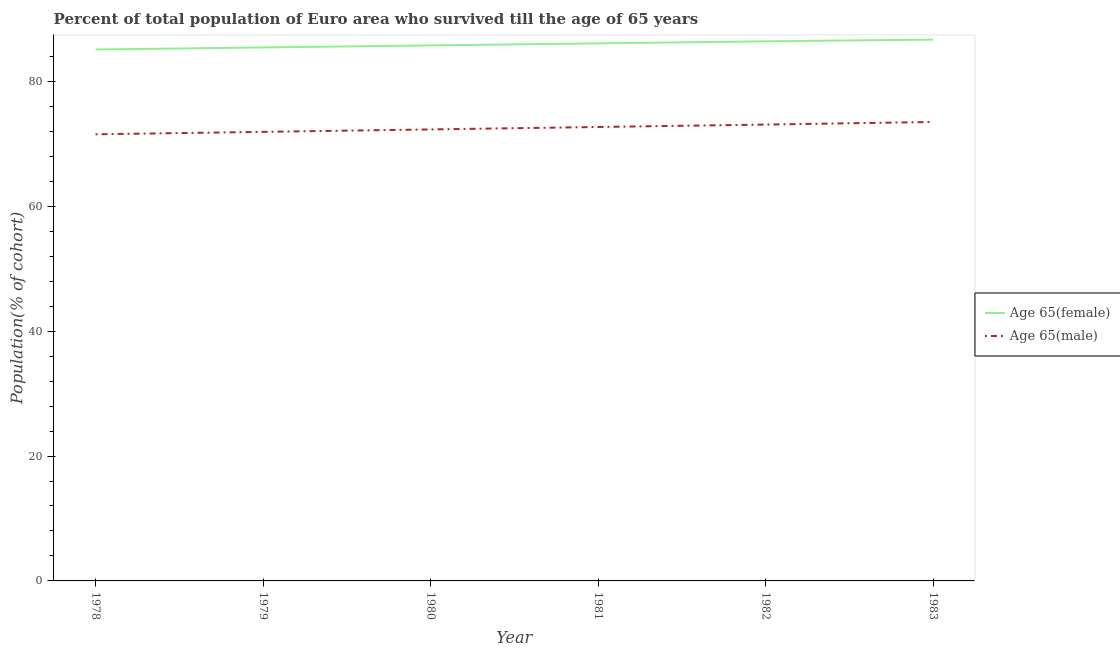How many different coloured lines are there?
Your response must be concise. 2. What is the percentage of female population who survived till age of 65 in 1982?
Make the answer very short. 86.42. Across all years, what is the maximum percentage of female population who survived till age of 65?
Provide a short and direct response. 86.69. Across all years, what is the minimum percentage of male population who survived till age of 65?
Offer a very short reply. 71.53. In which year was the percentage of male population who survived till age of 65 minimum?
Give a very brief answer. 1978. What is the total percentage of male population who survived till age of 65 in the graph?
Offer a terse response. 435.04. What is the difference between the percentage of male population who survived till age of 65 in 1981 and that in 1982?
Offer a terse response. -0.39. What is the difference between the percentage of male population who survived till age of 65 in 1983 and the percentage of female population who survived till age of 65 in 1978?
Provide a short and direct response. -11.61. What is the average percentage of male population who survived till age of 65 per year?
Provide a short and direct response. 72.51. In the year 1983, what is the difference between the percentage of female population who survived till age of 65 and percentage of male population who survived till age of 65?
Provide a succinct answer. 13.19. What is the ratio of the percentage of female population who survived till age of 65 in 1978 to that in 1979?
Give a very brief answer. 1. Is the percentage of female population who survived till age of 65 in 1980 less than that in 1983?
Your response must be concise. Yes. What is the difference between the highest and the second highest percentage of female population who survived till age of 65?
Make the answer very short. 0.28. What is the difference between the highest and the lowest percentage of male population who survived till age of 65?
Provide a succinct answer. 1.97. Is the sum of the percentage of male population who survived till age of 65 in 1978 and 1982 greater than the maximum percentage of female population who survived till age of 65 across all years?
Keep it short and to the point. Yes. Does the percentage of female population who survived till age of 65 monotonically increase over the years?
Make the answer very short. Yes. Is the percentage of male population who survived till age of 65 strictly greater than the percentage of female population who survived till age of 65 over the years?
Your response must be concise. No. Is the percentage of male population who survived till age of 65 strictly less than the percentage of female population who survived till age of 65 over the years?
Give a very brief answer. Yes. How many lines are there?
Offer a very short reply. 2. How many years are there in the graph?
Give a very brief answer. 6. What is the difference between two consecutive major ticks on the Y-axis?
Ensure brevity in your answer.  20. Are the values on the major ticks of Y-axis written in scientific E-notation?
Offer a terse response. No. Does the graph contain grids?
Provide a succinct answer. No. Where does the legend appear in the graph?
Ensure brevity in your answer.  Center right. How many legend labels are there?
Give a very brief answer. 2. What is the title of the graph?
Your answer should be compact. Percent of total population of Euro area who survived till the age of 65 years. What is the label or title of the Y-axis?
Ensure brevity in your answer.  Population(% of cohort). What is the Population(% of cohort) in Age 65(female) in 1978?
Your answer should be very brief. 85.11. What is the Population(% of cohort) in Age 65(male) in 1978?
Your answer should be compact. 71.53. What is the Population(% of cohort) in Age 65(female) in 1979?
Keep it short and to the point. 85.44. What is the Population(% of cohort) of Age 65(male) in 1979?
Make the answer very short. 71.92. What is the Population(% of cohort) of Age 65(female) in 1980?
Make the answer very short. 85.76. What is the Population(% of cohort) in Age 65(male) in 1980?
Make the answer very short. 72.31. What is the Population(% of cohort) in Age 65(female) in 1981?
Your answer should be compact. 86.09. What is the Population(% of cohort) of Age 65(male) in 1981?
Ensure brevity in your answer.  72.7. What is the Population(% of cohort) of Age 65(female) in 1982?
Keep it short and to the point. 86.42. What is the Population(% of cohort) in Age 65(male) in 1982?
Ensure brevity in your answer.  73.09. What is the Population(% of cohort) in Age 65(female) in 1983?
Provide a succinct answer. 86.69. What is the Population(% of cohort) of Age 65(male) in 1983?
Offer a very short reply. 73.5. Across all years, what is the maximum Population(% of cohort) of Age 65(female)?
Offer a very short reply. 86.69. Across all years, what is the maximum Population(% of cohort) in Age 65(male)?
Provide a succinct answer. 73.5. Across all years, what is the minimum Population(% of cohort) in Age 65(female)?
Your response must be concise. 85.11. Across all years, what is the minimum Population(% of cohort) in Age 65(male)?
Offer a very short reply. 71.53. What is the total Population(% of cohort) of Age 65(female) in the graph?
Your response must be concise. 515.51. What is the total Population(% of cohort) in Age 65(male) in the graph?
Offer a terse response. 435.04. What is the difference between the Population(% of cohort) in Age 65(female) in 1978 and that in 1979?
Offer a terse response. -0.33. What is the difference between the Population(% of cohort) of Age 65(male) in 1978 and that in 1979?
Make the answer very short. -0.39. What is the difference between the Population(% of cohort) in Age 65(female) in 1978 and that in 1980?
Your answer should be very brief. -0.65. What is the difference between the Population(% of cohort) in Age 65(male) in 1978 and that in 1980?
Your response must be concise. -0.78. What is the difference between the Population(% of cohort) in Age 65(female) in 1978 and that in 1981?
Keep it short and to the point. -0.98. What is the difference between the Population(% of cohort) in Age 65(male) in 1978 and that in 1981?
Keep it short and to the point. -1.17. What is the difference between the Population(% of cohort) of Age 65(female) in 1978 and that in 1982?
Ensure brevity in your answer.  -1.31. What is the difference between the Population(% of cohort) of Age 65(male) in 1978 and that in 1982?
Provide a short and direct response. -1.56. What is the difference between the Population(% of cohort) of Age 65(female) in 1978 and that in 1983?
Provide a succinct answer. -1.58. What is the difference between the Population(% of cohort) of Age 65(male) in 1978 and that in 1983?
Your answer should be very brief. -1.97. What is the difference between the Population(% of cohort) of Age 65(female) in 1979 and that in 1980?
Give a very brief answer. -0.33. What is the difference between the Population(% of cohort) in Age 65(male) in 1979 and that in 1980?
Provide a short and direct response. -0.39. What is the difference between the Population(% of cohort) in Age 65(female) in 1979 and that in 1981?
Offer a very short reply. -0.65. What is the difference between the Population(% of cohort) in Age 65(male) in 1979 and that in 1981?
Provide a short and direct response. -0.78. What is the difference between the Population(% of cohort) of Age 65(female) in 1979 and that in 1982?
Your answer should be compact. -0.98. What is the difference between the Population(% of cohort) of Age 65(male) in 1979 and that in 1982?
Your response must be concise. -1.17. What is the difference between the Population(% of cohort) in Age 65(female) in 1979 and that in 1983?
Your answer should be compact. -1.26. What is the difference between the Population(% of cohort) of Age 65(male) in 1979 and that in 1983?
Keep it short and to the point. -1.58. What is the difference between the Population(% of cohort) in Age 65(female) in 1980 and that in 1981?
Ensure brevity in your answer.  -0.33. What is the difference between the Population(% of cohort) of Age 65(male) in 1980 and that in 1981?
Your answer should be compact. -0.39. What is the difference between the Population(% of cohort) of Age 65(female) in 1980 and that in 1982?
Your answer should be very brief. -0.65. What is the difference between the Population(% of cohort) of Age 65(male) in 1980 and that in 1982?
Keep it short and to the point. -0.78. What is the difference between the Population(% of cohort) in Age 65(female) in 1980 and that in 1983?
Your response must be concise. -0.93. What is the difference between the Population(% of cohort) of Age 65(male) in 1980 and that in 1983?
Ensure brevity in your answer.  -1.19. What is the difference between the Population(% of cohort) in Age 65(female) in 1981 and that in 1982?
Ensure brevity in your answer.  -0.33. What is the difference between the Population(% of cohort) in Age 65(male) in 1981 and that in 1982?
Make the answer very short. -0.39. What is the difference between the Population(% of cohort) of Age 65(female) in 1981 and that in 1983?
Offer a terse response. -0.6. What is the difference between the Population(% of cohort) in Age 65(male) in 1981 and that in 1983?
Your answer should be very brief. -0.81. What is the difference between the Population(% of cohort) of Age 65(female) in 1982 and that in 1983?
Your response must be concise. -0.28. What is the difference between the Population(% of cohort) in Age 65(male) in 1982 and that in 1983?
Your answer should be compact. -0.42. What is the difference between the Population(% of cohort) of Age 65(female) in 1978 and the Population(% of cohort) of Age 65(male) in 1979?
Give a very brief answer. 13.19. What is the difference between the Population(% of cohort) of Age 65(female) in 1978 and the Population(% of cohort) of Age 65(male) in 1980?
Offer a very short reply. 12.8. What is the difference between the Population(% of cohort) of Age 65(female) in 1978 and the Population(% of cohort) of Age 65(male) in 1981?
Make the answer very short. 12.41. What is the difference between the Population(% of cohort) in Age 65(female) in 1978 and the Population(% of cohort) in Age 65(male) in 1982?
Your answer should be compact. 12.02. What is the difference between the Population(% of cohort) of Age 65(female) in 1978 and the Population(% of cohort) of Age 65(male) in 1983?
Your answer should be compact. 11.61. What is the difference between the Population(% of cohort) of Age 65(female) in 1979 and the Population(% of cohort) of Age 65(male) in 1980?
Offer a terse response. 13.13. What is the difference between the Population(% of cohort) of Age 65(female) in 1979 and the Population(% of cohort) of Age 65(male) in 1981?
Make the answer very short. 12.74. What is the difference between the Population(% of cohort) in Age 65(female) in 1979 and the Population(% of cohort) in Age 65(male) in 1982?
Offer a terse response. 12.35. What is the difference between the Population(% of cohort) in Age 65(female) in 1979 and the Population(% of cohort) in Age 65(male) in 1983?
Give a very brief answer. 11.93. What is the difference between the Population(% of cohort) of Age 65(female) in 1980 and the Population(% of cohort) of Age 65(male) in 1981?
Your answer should be very brief. 13.07. What is the difference between the Population(% of cohort) of Age 65(female) in 1980 and the Population(% of cohort) of Age 65(male) in 1982?
Make the answer very short. 12.68. What is the difference between the Population(% of cohort) in Age 65(female) in 1980 and the Population(% of cohort) in Age 65(male) in 1983?
Offer a terse response. 12.26. What is the difference between the Population(% of cohort) in Age 65(female) in 1981 and the Population(% of cohort) in Age 65(male) in 1982?
Your answer should be very brief. 13. What is the difference between the Population(% of cohort) in Age 65(female) in 1981 and the Population(% of cohort) in Age 65(male) in 1983?
Your response must be concise. 12.59. What is the difference between the Population(% of cohort) in Age 65(female) in 1982 and the Population(% of cohort) in Age 65(male) in 1983?
Your answer should be compact. 12.91. What is the average Population(% of cohort) of Age 65(female) per year?
Offer a terse response. 85.92. What is the average Population(% of cohort) in Age 65(male) per year?
Give a very brief answer. 72.51. In the year 1978, what is the difference between the Population(% of cohort) of Age 65(female) and Population(% of cohort) of Age 65(male)?
Keep it short and to the point. 13.58. In the year 1979, what is the difference between the Population(% of cohort) in Age 65(female) and Population(% of cohort) in Age 65(male)?
Offer a very short reply. 13.52. In the year 1980, what is the difference between the Population(% of cohort) in Age 65(female) and Population(% of cohort) in Age 65(male)?
Give a very brief answer. 13.46. In the year 1981, what is the difference between the Population(% of cohort) of Age 65(female) and Population(% of cohort) of Age 65(male)?
Keep it short and to the point. 13.39. In the year 1982, what is the difference between the Population(% of cohort) of Age 65(female) and Population(% of cohort) of Age 65(male)?
Give a very brief answer. 13.33. In the year 1983, what is the difference between the Population(% of cohort) of Age 65(female) and Population(% of cohort) of Age 65(male)?
Provide a short and direct response. 13.19. What is the ratio of the Population(% of cohort) of Age 65(male) in 1978 to that in 1981?
Your response must be concise. 0.98. What is the ratio of the Population(% of cohort) in Age 65(female) in 1978 to that in 1982?
Keep it short and to the point. 0.98. What is the ratio of the Population(% of cohort) of Age 65(male) in 1978 to that in 1982?
Provide a short and direct response. 0.98. What is the ratio of the Population(% of cohort) in Age 65(female) in 1978 to that in 1983?
Ensure brevity in your answer.  0.98. What is the ratio of the Population(% of cohort) of Age 65(male) in 1978 to that in 1983?
Make the answer very short. 0.97. What is the ratio of the Population(% of cohort) of Age 65(male) in 1979 to that in 1980?
Ensure brevity in your answer.  0.99. What is the ratio of the Population(% of cohort) in Age 65(male) in 1979 to that in 1981?
Your answer should be very brief. 0.99. What is the ratio of the Population(% of cohort) of Age 65(female) in 1979 to that in 1982?
Make the answer very short. 0.99. What is the ratio of the Population(% of cohort) of Age 65(male) in 1979 to that in 1982?
Provide a short and direct response. 0.98. What is the ratio of the Population(% of cohort) in Age 65(female) in 1979 to that in 1983?
Give a very brief answer. 0.99. What is the ratio of the Population(% of cohort) of Age 65(male) in 1979 to that in 1983?
Offer a terse response. 0.98. What is the ratio of the Population(% of cohort) in Age 65(male) in 1980 to that in 1982?
Provide a succinct answer. 0.99. What is the ratio of the Population(% of cohort) of Age 65(female) in 1980 to that in 1983?
Your response must be concise. 0.99. What is the ratio of the Population(% of cohort) of Age 65(male) in 1980 to that in 1983?
Offer a very short reply. 0.98. What is the ratio of the Population(% of cohort) in Age 65(male) in 1981 to that in 1982?
Provide a short and direct response. 0.99. What is the ratio of the Population(% of cohort) of Age 65(female) in 1981 to that in 1983?
Ensure brevity in your answer.  0.99. What is the ratio of the Population(% of cohort) of Age 65(male) in 1981 to that in 1983?
Your answer should be very brief. 0.99. What is the ratio of the Population(% of cohort) in Age 65(male) in 1982 to that in 1983?
Give a very brief answer. 0.99. What is the difference between the highest and the second highest Population(% of cohort) in Age 65(female)?
Keep it short and to the point. 0.28. What is the difference between the highest and the second highest Population(% of cohort) of Age 65(male)?
Make the answer very short. 0.42. What is the difference between the highest and the lowest Population(% of cohort) of Age 65(female)?
Offer a terse response. 1.58. What is the difference between the highest and the lowest Population(% of cohort) in Age 65(male)?
Your answer should be compact. 1.97. 